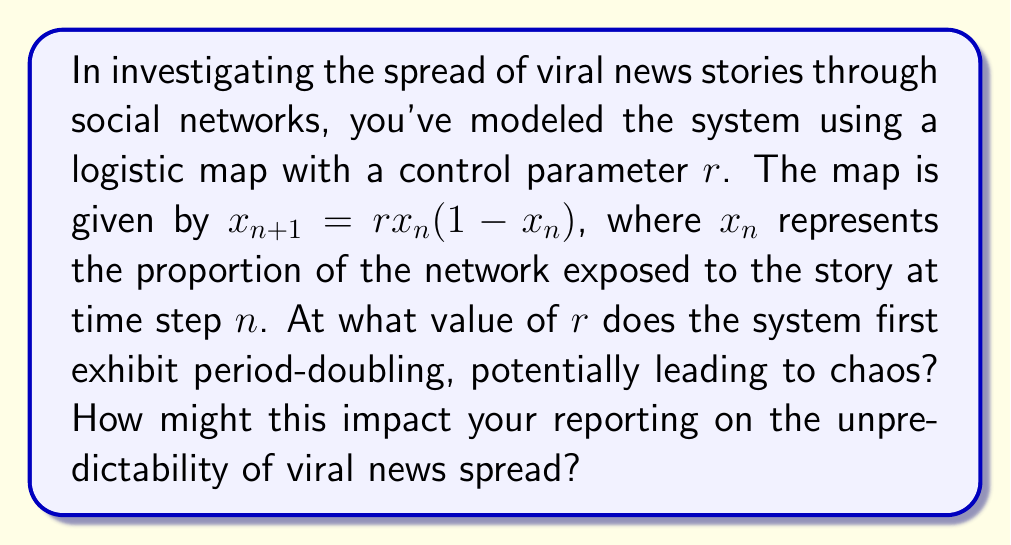Could you help me with this problem? To solve this problem, we need to analyze the logistic map using bifurcation theory:

1) The logistic map is given by:
   $$x_{n+1} = rx_n(1-x_n)$$

2) For small values of $r$, the system has a stable fixed point. As $r$ increases, the system undergoes bifurcations.

3) The first bifurcation (period-doubling) occurs when the stability of the fixed point changes. This happens when the absolute value of the derivative at the fixed point equals 1.

4) The fixed point $x^*$ of the logistic map satisfies:
   $$x^* = rx^*(1-x^*)$$

5) Solving this equation:
   $$x^* = 0$$ or $$x^* = 1 - \frac{1}{r}$$

6) The non-zero fixed point is $x^* = 1 - \frac{1}{r}$

7) The derivative of the logistic map is:
   $$f'(x) = r(1-2x)$$

8) At the fixed point:
   $$f'(x^*) = r(1-2(1-\frac{1}{r})) = r(1-2+\frac{2}{r}) = 2-r$$

9) The period-doubling occurs when $|f'(x^*)| = 1$:
   $$|2-r| = 1$$

10) Solving this equation:
    $$r = 3$$

This value of $r=3$ marks the onset of period-doubling, which can lead to chaos for higher values of $r$. In the context of viral news spread, this suggests that beyond a certain threshold of network reactivity (represented by $r$), the system's behavior becomes increasingly unpredictable. This unpredictability could manifest as sudden viral surges or unexpected die-outs of news stories, challenging traditional models of news dissemination and consumption.
Answer: $r = 3$ 